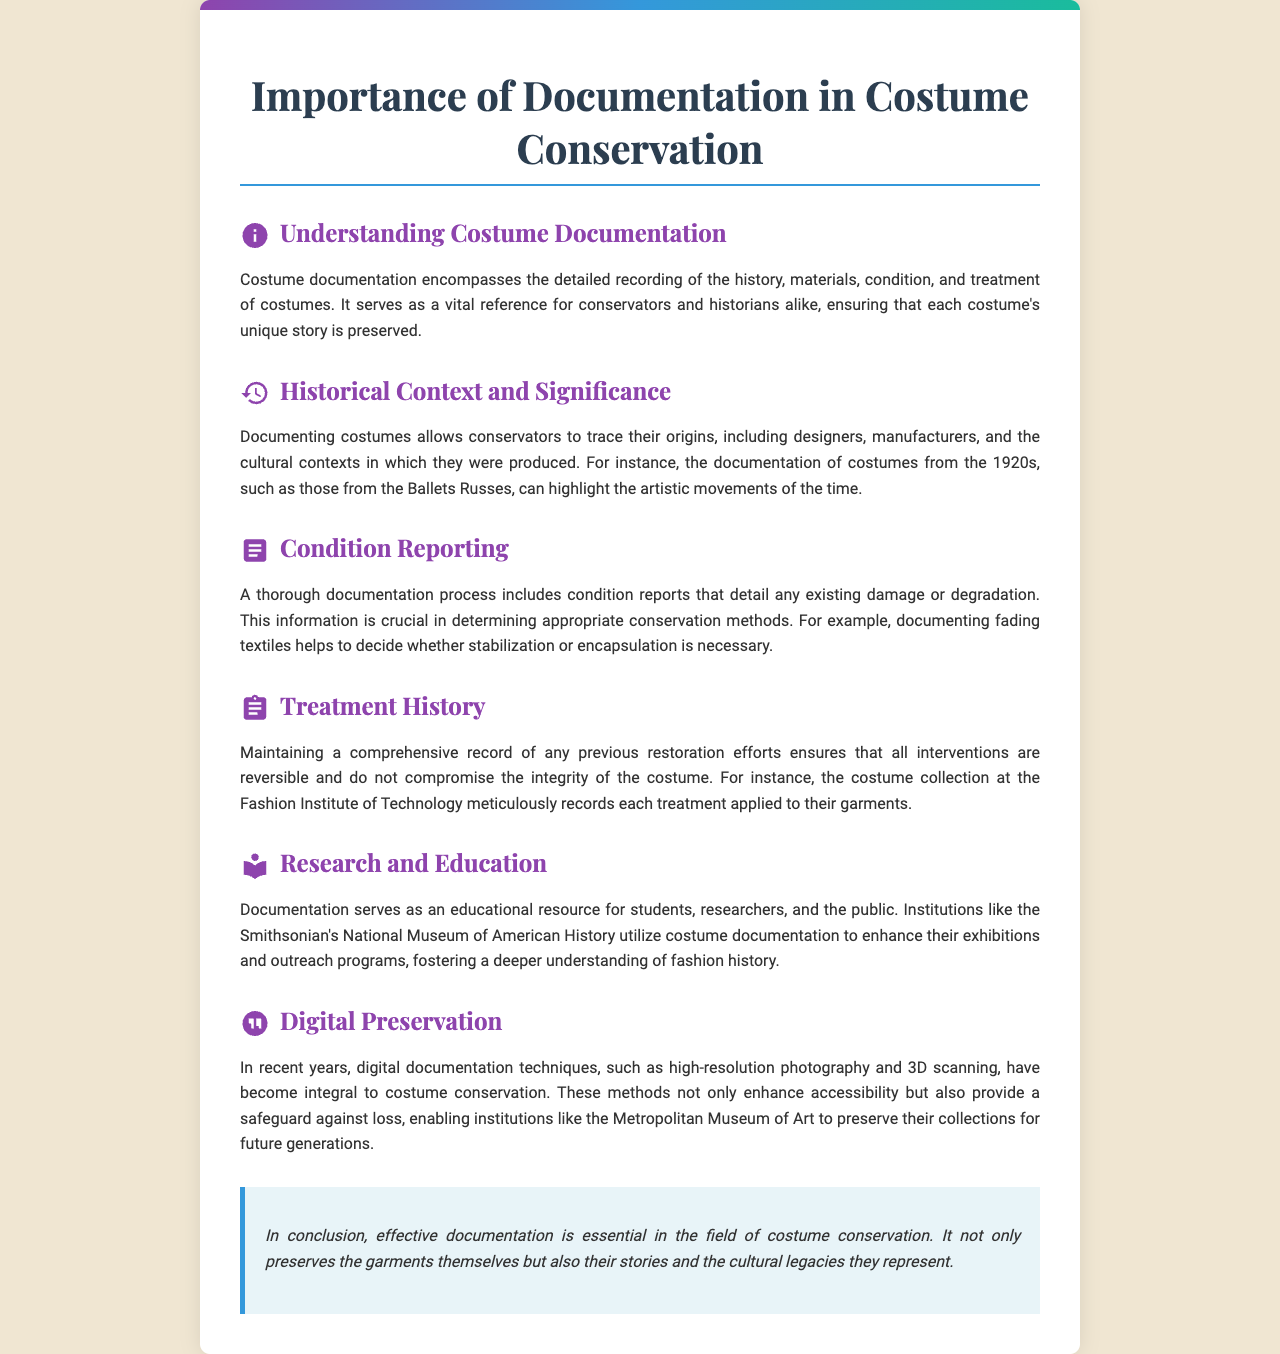What is the title of the brochure? The title is prominently displayed at the top of the document, which is about the significance of documentation in a specific context.
Answer: Importance of Documentation in Costume Conservation What are the three main components of costume documentation? The document outlines key areas of focus within costume documentation.
Answer: History, materials, condition In which cultural context are the costumes from the 1920s mentioned? This detail is found within the section that discusses the historical context and significance of the costumes.
Answer: Ballets Russes What method is crucial for determining appropriate conservation methods? This method gives insight into the necessary steps for effective preservation of costumes.
Answer: Condition reporting Which institution meticulously records each treatment applied to their garments? This organization is cited to illustrate how treatment history is documented effectively.
Answer: Fashion Institute of Technology What two digital techniques are mentioned for preserving costume documentation? This highlights the modern methods used for conservation in the document.
Answer: High-resolution photography, 3D scanning What type of resource does documentation serve for students and researchers? This explains the educational role of documentation as described in the document.
Answer: Educational resource What is the concluding point about the importance of effective documentation? The conclusion emphasizes its overall significance in preserving not just garments but cultural narratives.
Answer: Preserves garments and their stories 